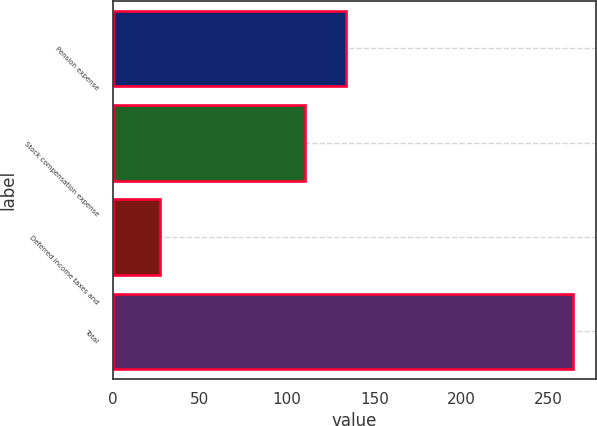Convert chart. <chart><loc_0><loc_0><loc_500><loc_500><bar_chart><fcel>Pension expense<fcel>Stock compensation expense<fcel>Deferred income taxes and<fcel>Total<nl><fcel>133.7<fcel>110<fcel>27<fcel>264<nl></chart> 